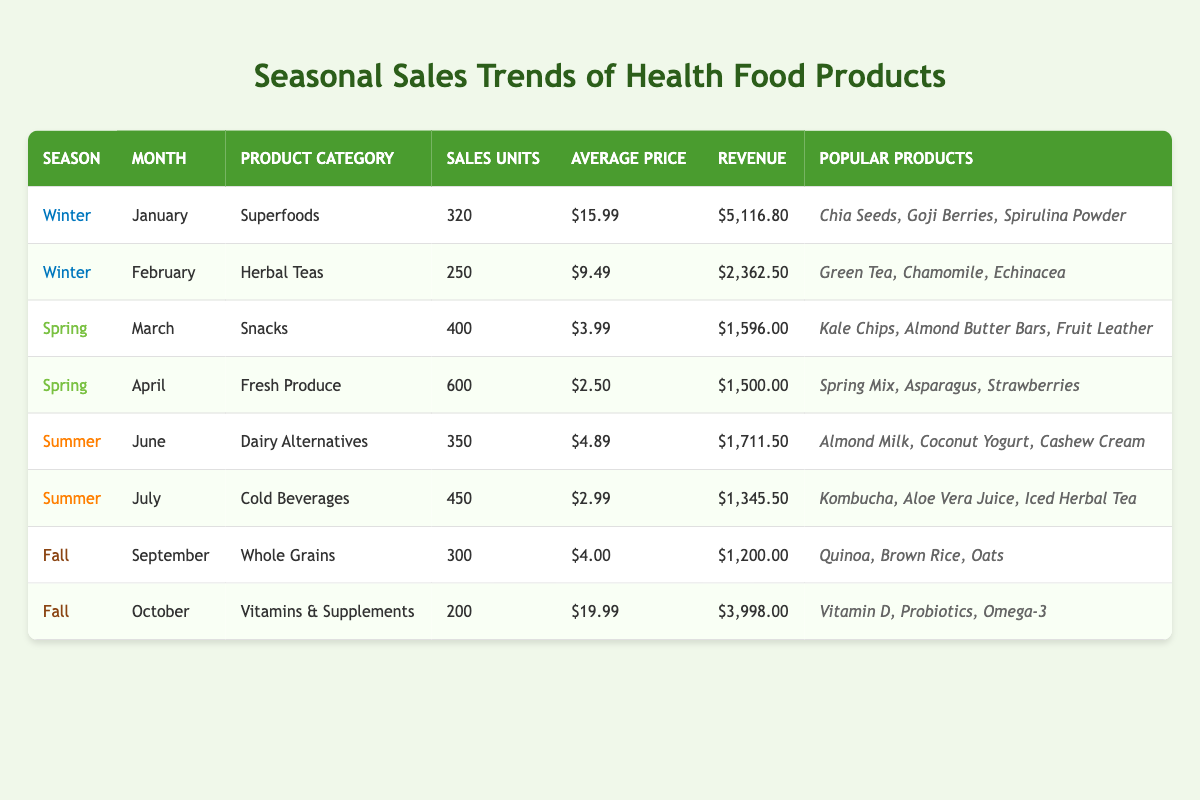What product category had the highest sales units in Spring? In Spring, the months listed are March and April. In March, "Snacks" had 400 sales units, and in April, "Fresh Produce" had 600 sales units. Therefore, "Fresh Produce" had the highest sales units in Spring.
Answer: Fresh Produce What was the total revenue generated from Winter months? For Winter, January generated $5,116.80 (Superfoods) and February generated $2,362.50 (Herbal Teas). Adding these gives: $5,116.80 + $2,362.50 = $7,479.30.
Answer: $7,479.30 Did "Vitamins & Supplements" have more sales units than "Whole Grains"? "Vitamins & Supplements" had 200 sales units in October, while "Whole Grains" had 300 sales units in September. Since 300 is greater than 200, the statement is false.
Answer: No Which season had the lowest average price for its products? Calculating the average price for each season: Winter ([$15.99 + $9.49]/2 = $12.74), Spring ([$3.99 + $2.50]/2 = $3.75), Summer ([$4.89 + $2.99]/2 = $3.94), Fall ([$4.00 + $19.99]/2 = $11.00). The lowest average price is from Spring, $3.75.
Answer: Spring What was the total sales units in Summer? Summer includes June with 350 and July with 450 sales units. Adding these gives 350 + 450 = 800.
Answer: 800 Which month generated the highest revenue, and how much was it? The maximum revenue is evaluated by checking each month: January ($5,116.80), February ($2,362.50), March ($1,596.00), April ($1,500.00), June ($1,711.50), July ($1,345.50), September ($1,200.00), and October ($3,998.00). January generated the highest revenue at $5,116.80.
Answer: January, $5,116.80 What percentage of sales units in Fall comes from "Whole Grains"? Fall has 300 sales units from Whole Grains in September and 200 from Vitamins & Supplements in October for a total of 500. The percentage is (300 / 500) * 100 = 60%.
Answer: 60% If you combine the revenue from both months in Summer, how much would that be? June generated $1,711.50 and July generated $1,345.50. Adding these two gives the total revenue: $1,711.50 + $1,345.50 = $3,057.00.
Answer: $3,057.00 How many sales units were sold for "Herbal Teas"? "Herbal Teas" is listed under February, having 250 sales units.
Answer: 250 Is "Kombucha" among the popular products in Spring? "Kombucha" is listed under Summer (July) as a popular product, not in Spring, which lists items from March and April. Thus, the statement is false.
Answer: No 